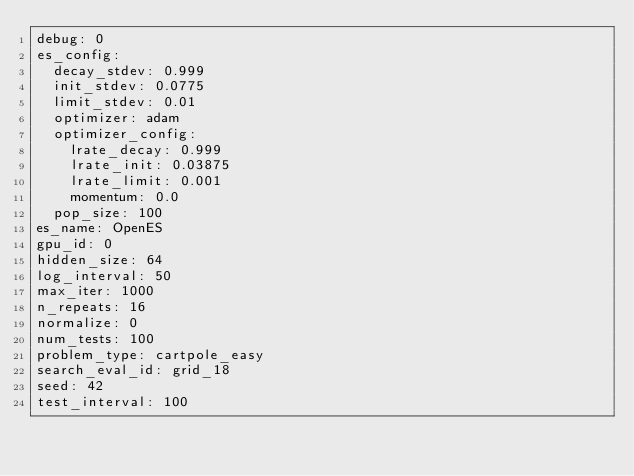<code> <loc_0><loc_0><loc_500><loc_500><_YAML_>debug: 0
es_config:
  decay_stdev: 0.999
  init_stdev: 0.0775
  limit_stdev: 0.01
  optimizer: adam
  optimizer_config:
    lrate_decay: 0.999
    lrate_init: 0.03875
    lrate_limit: 0.001
    momentum: 0.0
  pop_size: 100
es_name: OpenES
gpu_id: 0
hidden_size: 64
log_interval: 50
max_iter: 1000
n_repeats: 16
normalize: 0
num_tests: 100
problem_type: cartpole_easy
search_eval_id: grid_18
seed: 42
test_interval: 100
</code> 